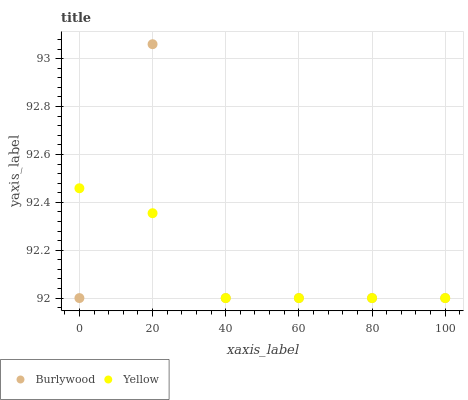Does Yellow have the minimum area under the curve?
Answer yes or no. Yes. Does Burlywood have the maximum area under the curve?
Answer yes or no. Yes. Does Yellow have the maximum area under the curve?
Answer yes or no. No. Is Yellow the smoothest?
Answer yes or no. Yes. Is Burlywood the roughest?
Answer yes or no. Yes. Is Yellow the roughest?
Answer yes or no. No. Does Burlywood have the lowest value?
Answer yes or no. Yes. Does Burlywood have the highest value?
Answer yes or no. Yes. Does Yellow have the highest value?
Answer yes or no. No. Does Burlywood intersect Yellow?
Answer yes or no. Yes. Is Burlywood less than Yellow?
Answer yes or no. No. Is Burlywood greater than Yellow?
Answer yes or no. No. 